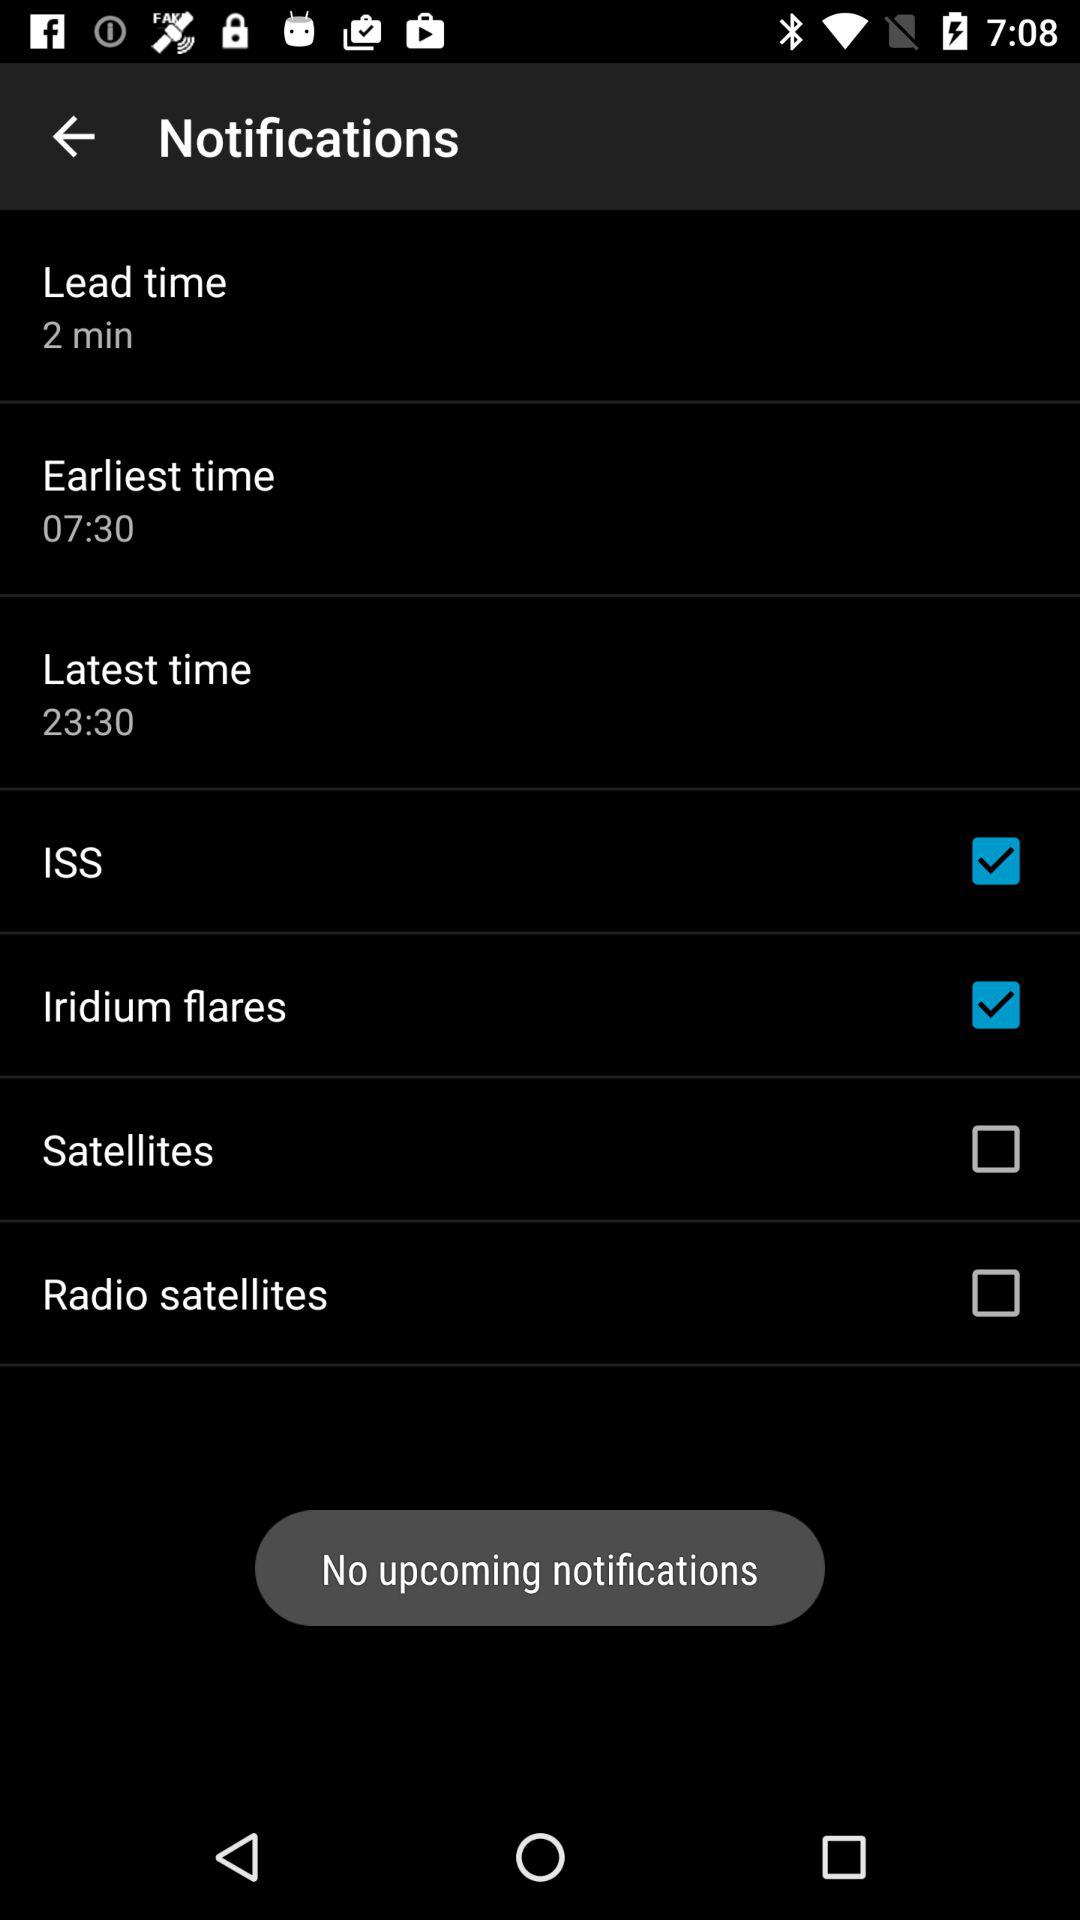What is the status of the ISS? The status is on. 